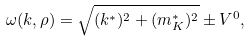<formula> <loc_0><loc_0><loc_500><loc_500>\omega ( { k } , \rho ) = \sqrt { ( { k } ^ { * } ) ^ { 2 } + ( m _ { K } ^ { * } ) ^ { 2 } } \pm V ^ { 0 } ,</formula> 